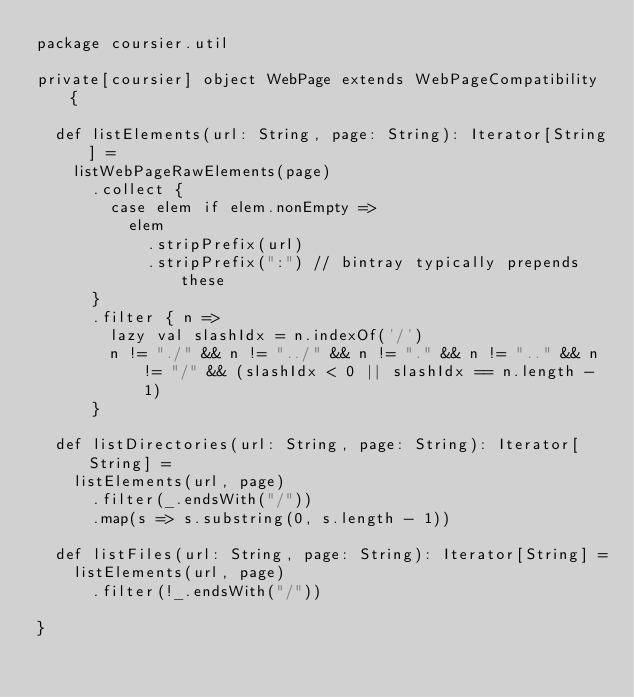<code> <loc_0><loc_0><loc_500><loc_500><_Scala_>package coursier.util

private[coursier] object WebPage extends WebPageCompatibility {

  def listElements(url: String, page: String): Iterator[String] =
    listWebPageRawElements(page)
      .collect {
        case elem if elem.nonEmpty =>
          elem
            .stripPrefix(url)
            .stripPrefix(":") // bintray typically prepends these
      }
      .filter { n =>
        lazy val slashIdx = n.indexOf('/')
        n != "./" && n != "../" && n != "." && n != ".." && n != "/" && (slashIdx < 0 || slashIdx == n.length - 1)
      }

  def listDirectories(url: String, page: String): Iterator[String] =
    listElements(url, page)
      .filter(_.endsWith("/"))
      .map(s => s.substring(0, s.length - 1))

  def listFiles(url: String, page: String): Iterator[String] =
    listElements(url, page)
      .filter(!_.endsWith("/"))

}</code> 